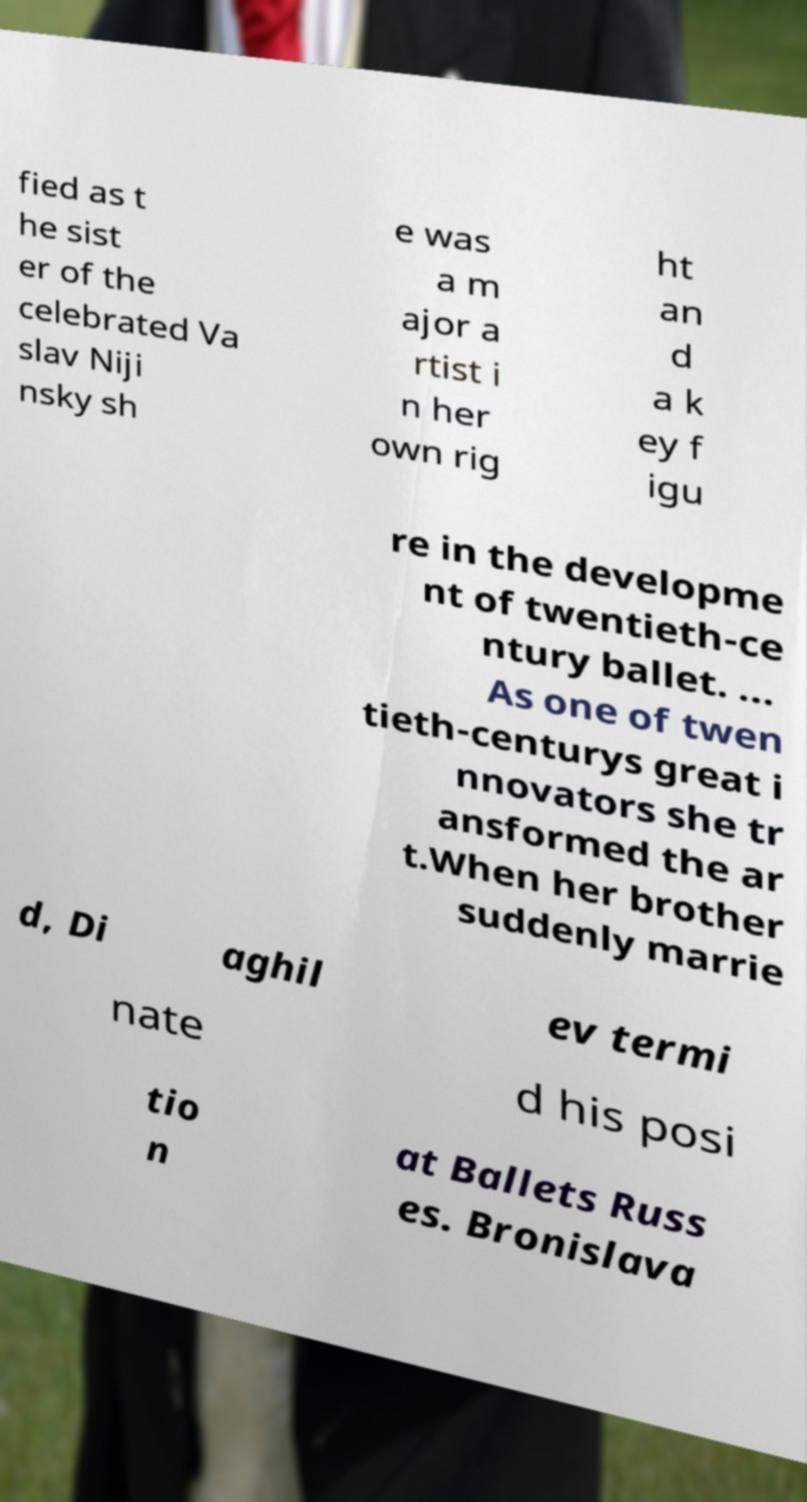Please identify and transcribe the text found in this image. fied as t he sist er of the celebrated Va slav Niji nsky sh e was a m ajor a rtist i n her own rig ht an d a k ey f igu re in the developme nt of twentieth-ce ntury ballet. ... As one of twen tieth-centurys great i nnovators she tr ansformed the ar t.When her brother suddenly marrie d, Di aghil ev termi nate d his posi tio n at Ballets Russ es. Bronislava 